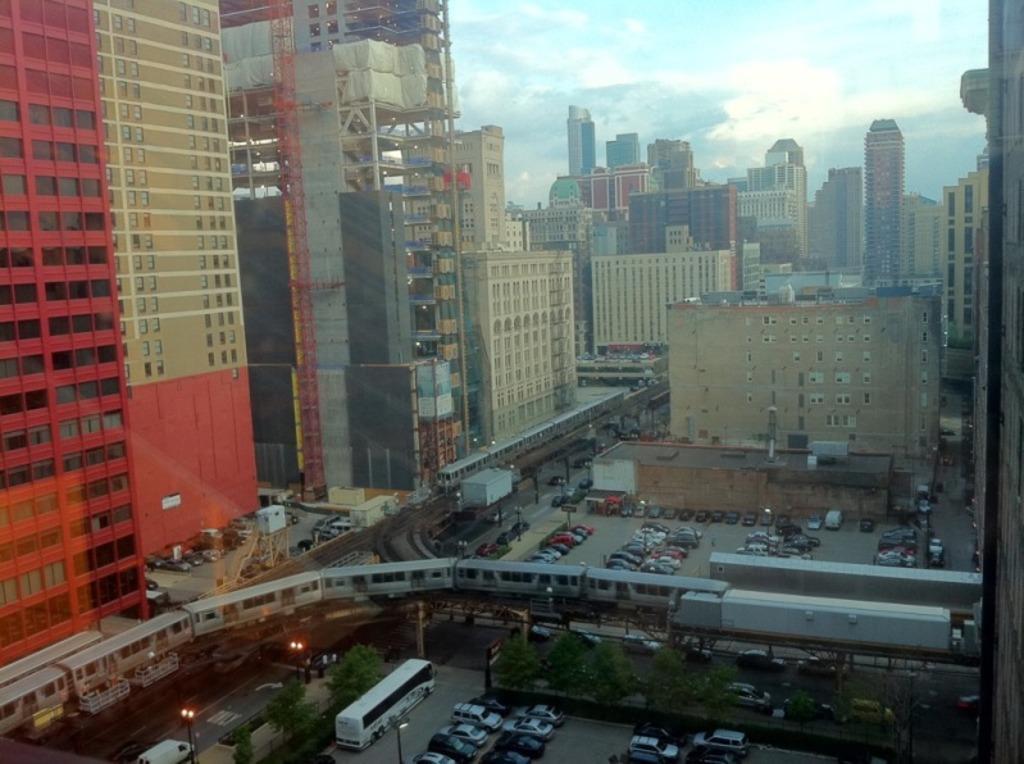Could you give a brief overview of what you see in this image? At the bottom of the image there are vehicles parked, beside this vehicle's there are few plants. On the road there are so many vehicles are passing, above the road there is a train on the track, beside this train there is another train is on the track. In the background there are buildings and sky. 